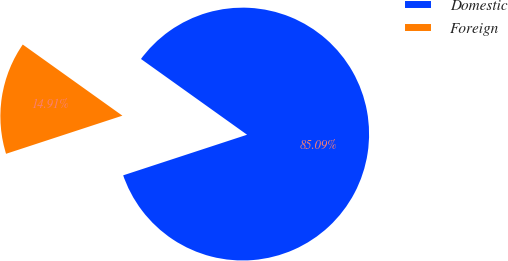Convert chart. <chart><loc_0><loc_0><loc_500><loc_500><pie_chart><fcel>Domestic<fcel>Foreign<nl><fcel>85.09%<fcel>14.91%<nl></chart> 